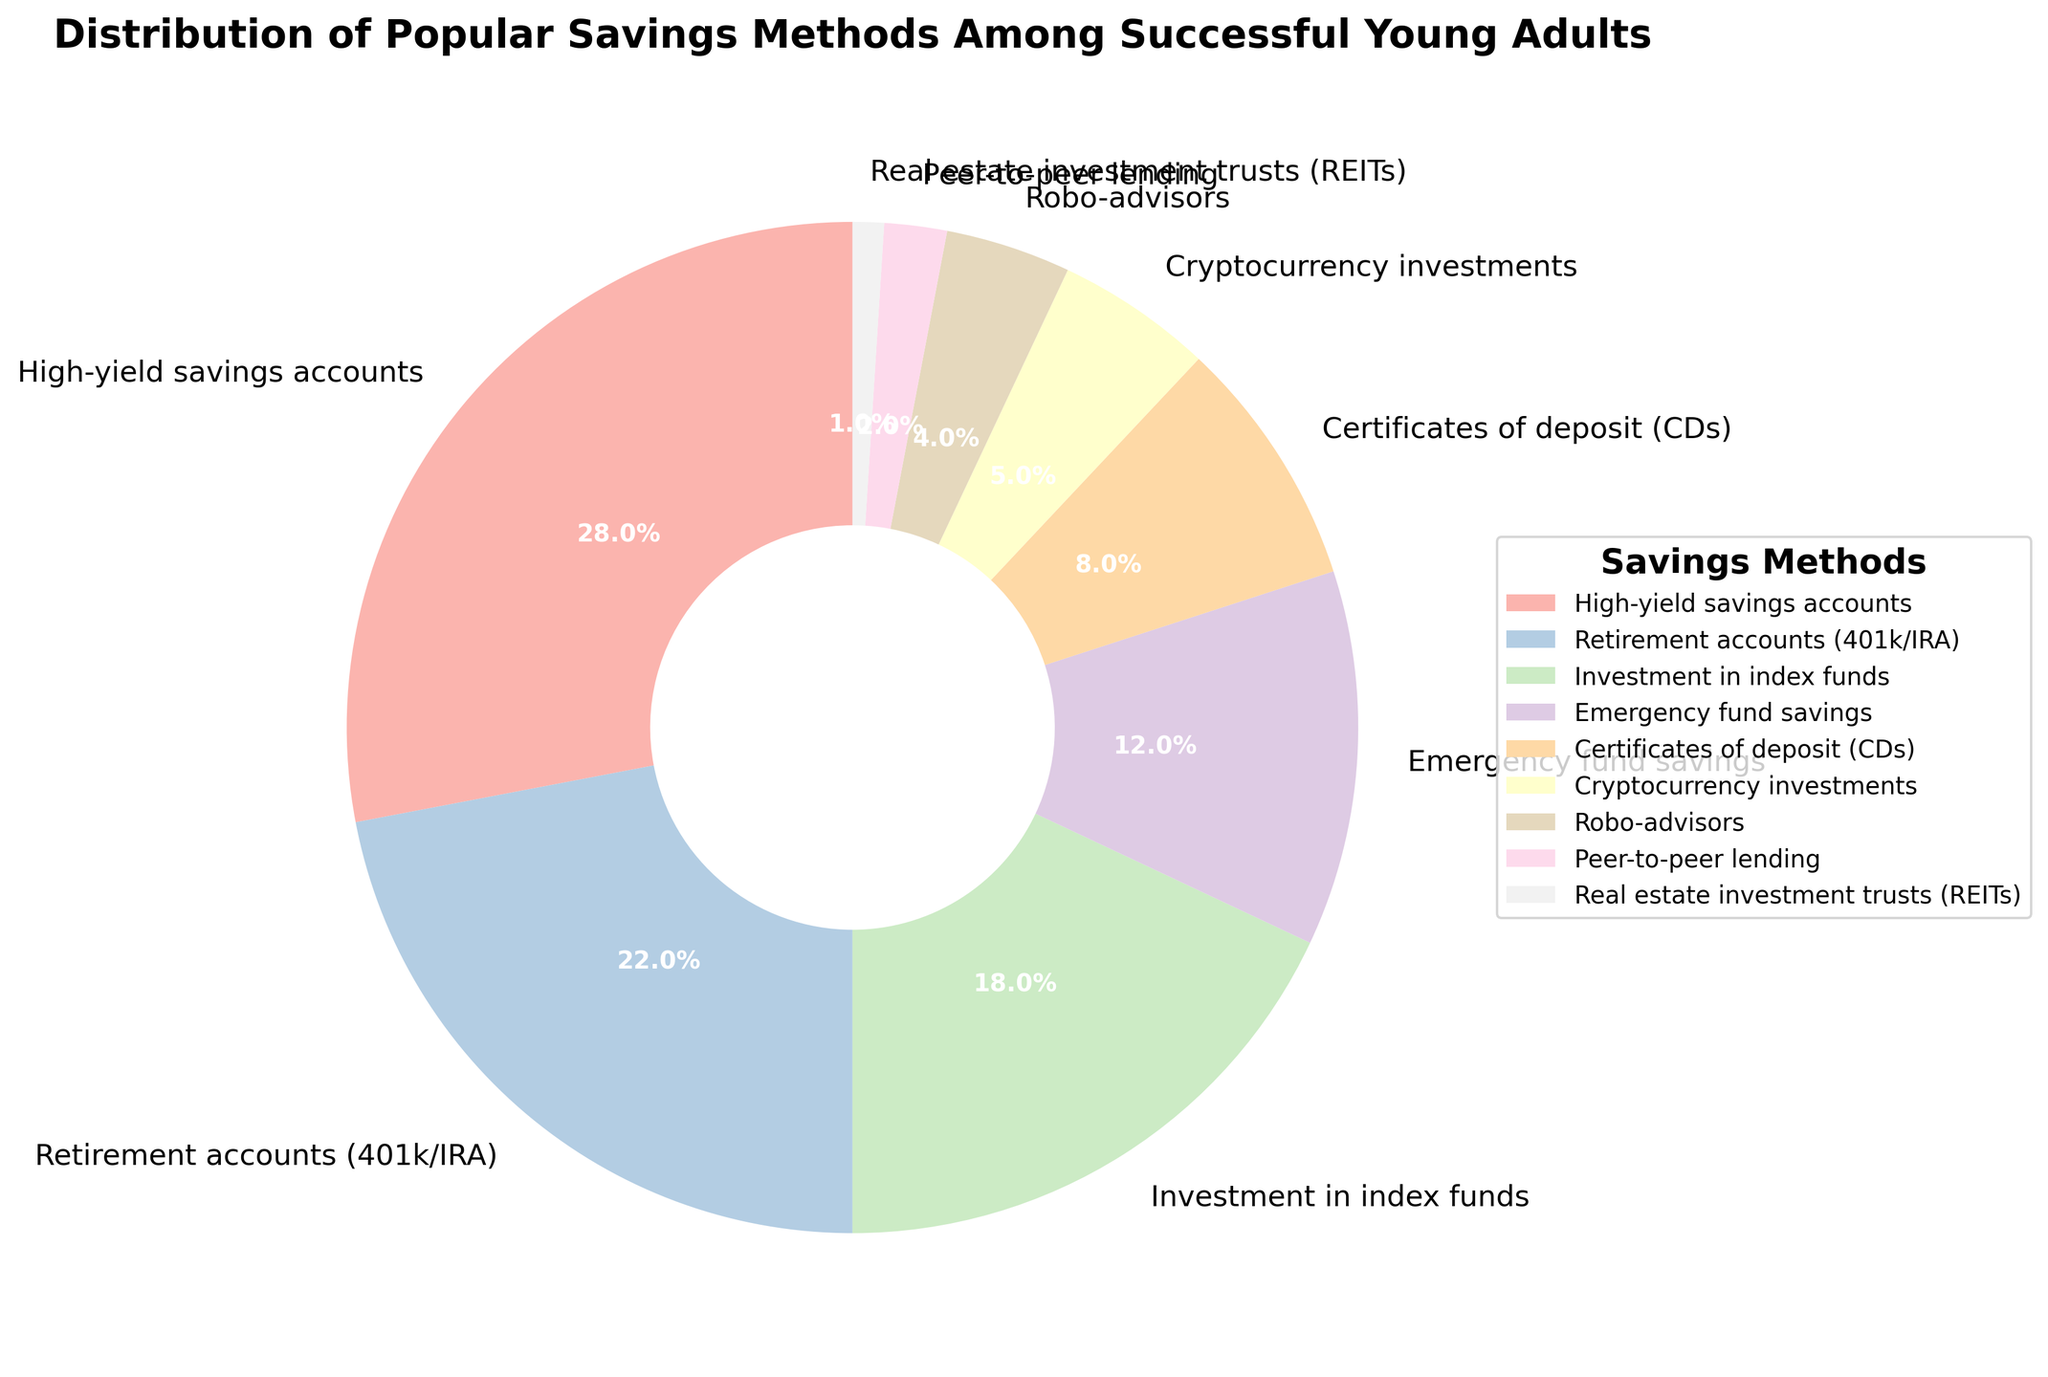which savings method has the highest percentage? The segment of the pie chart labeled "High-yield savings accounts" has the highest percentage as indicated by the 28% label.
Answer: High-yield savings accounts What percentage of young adults invest in retirement accounts (401k/IRA)? Looking at the segment labeled "Retirement accounts (401k/IRA)", it shows 22%.
Answer: 22% Which two savings methods combined make up exactly 30% of the total? Peer-to-peer lending (2%) and Cryptocurrency investments (5%) combined with Certificates of deposit (CDs) (8%) make up 15% which does not fit, but Emergency fund savings (12%) combined with Investment in index funds (18%) make up exactly 30%.
Answer: Emergency fund savings and Investment in index funds Are there more young adults investing in real estate investment trusts (REITs) or robo-advisors? The segment for robo-advisors is 4%, while that for real estate investment trusts (REITs) is only 1%, so more young adults are investing in robo-advisors.
Answer: Robo-advisors What is the combined percentage of young adults who use investment in index funds and cryptocurrency investments? Investment in index funds has 18% and cryptocurrency investments have 5%, their combined percentage is 18% + 5% = 23%.
Answer: 23% Which category shares the same color family in the pie chart? By visually examining the color family in the pie chart, Investment in index funds (18%) and Cryptocurrency investments (5%) share a similar color.
Answer: Investment in index funds and Cryptocurrency investments What percentage more do young adults save in high-yield savings accounts compared to robo-advisors? High-yield savings accounts have a percentage of 28%, and robo-advisors have 4%. The difference is 28% - 4% = 24%.
Answer: 24 % If you combine the percentages of using high-yield savings accounts, retirement accounts, and emergency fund savings, what value do you get? High-yield savings accounts have 28%, retirement accounts have 22%, and emergency fund savings have 12%. Their sum is 28% + 22% + 12% = 62%.
Answer: 62% Which savings methods collectively contribute less than 10% to the total distribution? The savings methods with less than 10% are Peer-to-peer lending (2%), Real estate investment trusts (REITs) (1%), and Robo-advisors (4%). Their collective contribution is 2% + 1% + 4% = 7%.
Answer: Peer-to-peer lending, Real estate investment trusts, and Robo-advisors What is the total percentage allocated to emergency fund savings and certificates of deposit (CDs)? Emergency fund savings have 12% and certificates of deposit (CDs) have 8%. Their combined total is 12% + 8% = 20%.
Answer: 20% 